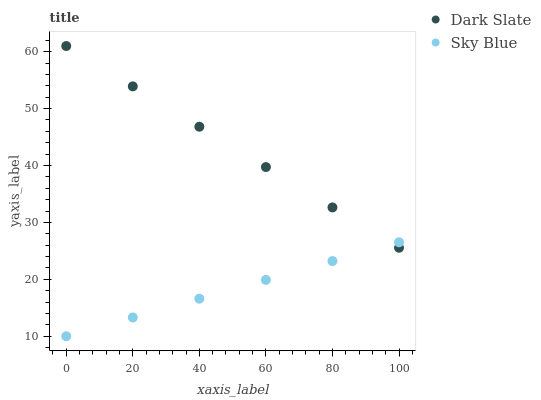Does Sky Blue have the minimum area under the curve?
Answer yes or no. Yes. Does Dark Slate have the maximum area under the curve?
Answer yes or no. Yes. Does Sky Blue have the maximum area under the curve?
Answer yes or no. No. Is Sky Blue the smoothest?
Answer yes or no. Yes. Is Dark Slate the roughest?
Answer yes or no. Yes. Is Sky Blue the roughest?
Answer yes or no. No. Does Sky Blue have the lowest value?
Answer yes or no. Yes. Does Dark Slate have the highest value?
Answer yes or no. Yes. Does Sky Blue have the highest value?
Answer yes or no. No. Does Sky Blue intersect Dark Slate?
Answer yes or no. Yes. Is Sky Blue less than Dark Slate?
Answer yes or no. No. Is Sky Blue greater than Dark Slate?
Answer yes or no. No. 